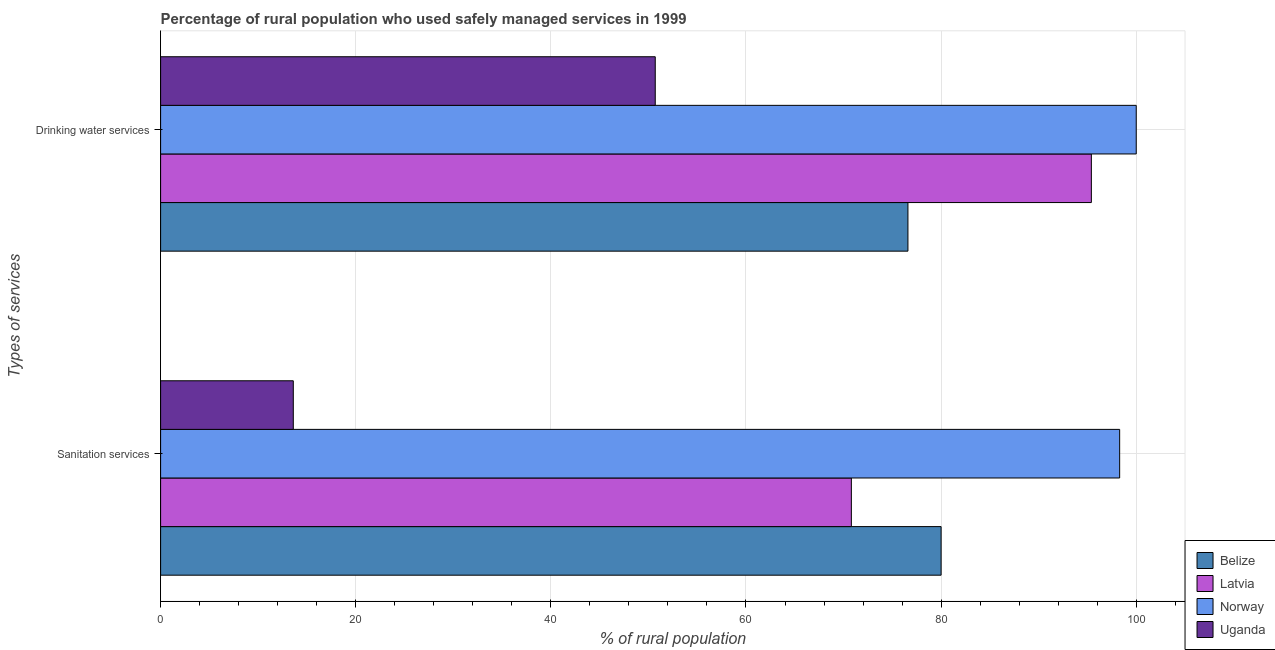How many different coloured bars are there?
Your answer should be compact. 4. Are the number of bars on each tick of the Y-axis equal?
Your answer should be very brief. Yes. How many bars are there on the 1st tick from the top?
Your response must be concise. 4. What is the label of the 2nd group of bars from the top?
Offer a very short reply. Sanitation services. What is the percentage of rural population who used sanitation services in Belize?
Offer a very short reply. 80. Across all countries, what is the minimum percentage of rural population who used sanitation services?
Provide a short and direct response. 13.6. In which country was the percentage of rural population who used drinking water services maximum?
Your answer should be very brief. Norway. In which country was the percentage of rural population who used drinking water services minimum?
Offer a terse response. Uganda. What is the total percentage of rural population who used sanitation services in the graph?
Give a very brief answer. 262.7. What is the difference between the percentage of rural population who used sanitation services in Belize and that in Uganda?
Offer a terse response. 66.4. What is the difference between the percentage of rural population who used drinking water services in Latvia and the percentage of rural population who used sanitation services in Uganda?
Your answer should be compact. 81.8. What is the average percentage of rural population who used drinking water services per country?
Offer a terse response. 80.67. What is the difference between the percentage of rural population who used sanitation services and percentage of rural population who used drinking water services in Belize?
Keep it short and to the point. 3.4. In how many countries, is the percentage of rural population who used drinking water services greater than 100 %?
Your answer should be compact. 0. What is the ratio of the percentage of rural population who used drinking water services in Latvia to that in Uganda?
Make the answer very short. 1.88. In how many countries, is the percentage of rural population who used drinking water services greater than the average percentage of rural population who used drinking water services taken over all countries?
Provide a short and direct response. 2. What does the 4th bar from the top in Sanitation services represents?
Your response must be concise. Belize. Are all the bars in the graph horizontal?
Your answer should be compact. Yes. What is the difference between two consecutive major ticks on the X-axis?
Offer a terse response. 20. Are the values on the major ticks of X-axis written in scientific E-notation?
Ensure brevity in your answer.  No. Does the graph contain any zero values?
Make the answer very short. No. How many legend labels are there?
Ensure brevity in your answer.  4. What is the title of the graph?
Provide a succinct answer. Percentage of rural population who used safely managed services in 1999. What is the label or title of the X-axis?
Provide a succinct answer. % of rural population. What is the label or title of the Y-axis?
Make the answer very short. Types of services. What is the % of rural population in Belize in Sanitation services?
Your answer should be very brief. 80. What is the % of rural population of Latvia in Sanitation services?
Ensure brevity in your answer.  70.8. What is the % of rural population of Norway in Sanitation services?
Your answer should be compact. 98.3. What is the % of rural population in Belize in Drinking water services?
Give a very brief answer. 76.6. What is the % of rural population in Latvia in Drinking water services?
Make the answer very short. 95.4. What is the % of rural population in Uganda in Drinking water services?
Give a very brief answer. 50.7. Across all Types of services, what is the maximum % of rural population in Latvia?
Make the answer very short. 95.4. Across all Types of services, what is the maximum % of rural population of Uganda?
Provide a succinct answer. 50.7. Across all Types of services, what is the minimum % of rural population of Belize?
Your answer should be very brief. 76.6. Across all Types of services, what is the minimum % of rural population of Latvia?
Your answer should be compact. 70.8. Across all Types of services, what is the minimum % of rural population of Norway?
Give a very brief answer. 98.3. Across all Types of services, what is the minimum % of rural population in Uganda?
Your response must be concise. 13.6. What is the total % of rural population of Belize in the graph?
Offer a terse response. 156.6. What is the total % of rural population in Latvia in the graph?
Give a very brief answer. 166.2. What is the total % of rural population in Norway in the graph?
Offer a very short reply. 198.3. What is the total % of rural population of Uganda in the graph?
Keep it short and to the point. 64.3. What is the difference between the % of rural population of Latvia in Sanitation services and that in Drinking water services?
Your answer should be compact. -24.6. What is the difference between the % of rural population in Norway in Sanitation services and that in Drinking water services?
Make the answer very short. -1.7. What is the difference between the % of rural population of Uganda in Sanitation services and that in Drinking water services?
Give a very brief answer. -37.1. What is the difference between the % of rural population of Belize in Sanitation services and the % of rural population of Latvia in Drinking water services?
Your response must be concise. -15.4. What is the difference between the % of rural population in Belize in Sanitation services and the % of rural population in Norway in Drinking water services?
Ensure brevity in your answer.  -20. What is the difference between the % of rural population of Belize in Sanitation services and the % of rural population of Uganda in Drinking water services?
Offer a very short reply. 29.3. What is the difference between the % of rural population in Latvia in Sanitation services and the % of rural population in Norway in Drinking water services?
Provide a short and direct response. -29.2. What is the difference between the % of rural population in Latvia in Sanitation services and the % of rural population in Uganda in Drinking water services?
Your answer should be compact. 20.1. What is the difference between the % of rural population in Norway in Sanitation services and the % of rural population in Uganda in Drinking water services?
Make the answer very short. 47.6. What is the average % of rural population in Belize per Types of services?
Offer a very short reply. 78.3. What is the average % of rural population in Latvia per Types of services?
Make the answer very short. 83.1. What is the average % of rural population in Norway per Types of services?
Your answer should be compact. 99.15. What is the average % of rural population in Uganda per Types of services?
Provide a succinct answer. 32.15. What is the difference between the % of rural population in Belize and % of rural population in Norway in Sanitation services?
Provide a succinct answer. -18.3. What is the difference between the % of rural population of Belize and % of rural population of Uganda in Sanitation services?
Your answer should be very brief. 66.4. What is the difference between the % of rural population in Latvia and % of rural population in Norway in Sanitation services?
Keep it short and to the point. -27.5. What is the difference between the % of rural population in Latvia and % of rural population in Uganda in Sanitation services?
Your response must be concise. 57.2. What is the difference between the % of rural population in Norway and % of rural population in Uganda in Sanitation services?
Keep it short and to the point. 84.7. What is the difference between the % of rural population in Belize and % of rural population in Latvia in Drinking water services?
Provide a short and direct response. -18.8. What is the difference between the % of rural population of Belize and % of rural population of Norway in Drinking water services?
Provide a short and direct response. -23.4. What is the difference between the % of rural population of Belize and % of rural population of Uganda in Drinking water services?
Keep it short and to the point. 25.9. What is the difference between the % of rural population in Latvia and % of rural population in Norway in Drinking water services?
Provide a short and direct response. -4.6. What is the difference between the % of rural population in Latvia and % of rural population in Uganda in Drinking water services?
Make the answer very short. 44.7. What is the difference between the % of rural population of Norway and % of rural population of Uganda in Drinking water services?
Provide a succinct answer. 49.3. What is the ratio of the % of rural population in Belize in Sanitation services to that in Drinking water services?
Your answer should be very brief. 1.04. What is the ratio of the % of rural population of Latvia in Sanitation services to that in Drinking water services?
Provide a succinct answer. 0.74. What is the ratio of the % of rural population in Norway in Sanitation services to that in Drinking water services?
Your response must be concise. 0.98. What is the ratio of the % of rural population of Uganda in Sanitation services to that in Drinking water services?
Your answer should be very brief. 0.27. What is the difference between the highest and the second highest % of rural population in Belize?
Give a very brief answer. 3.4. What is the difference between the highest and the second highest % of rural population of Latvia?
Offer a very short reply. 24.6. What is the difference between the highest and the second highest % of rural population of Uganda?
Provide a short and direct response. 37.1. What is the difference between the highest and the lowest % of rural population of Belize?
Your answer should be very brief. 3.4. What is the difference between the highest and the lowest % of rural population in Latvia?
Provide a succinct answer. 24.6. What is the difference between the highest and the lowest % of rural population of Uganda?
Your response must be concise. 37.1. 